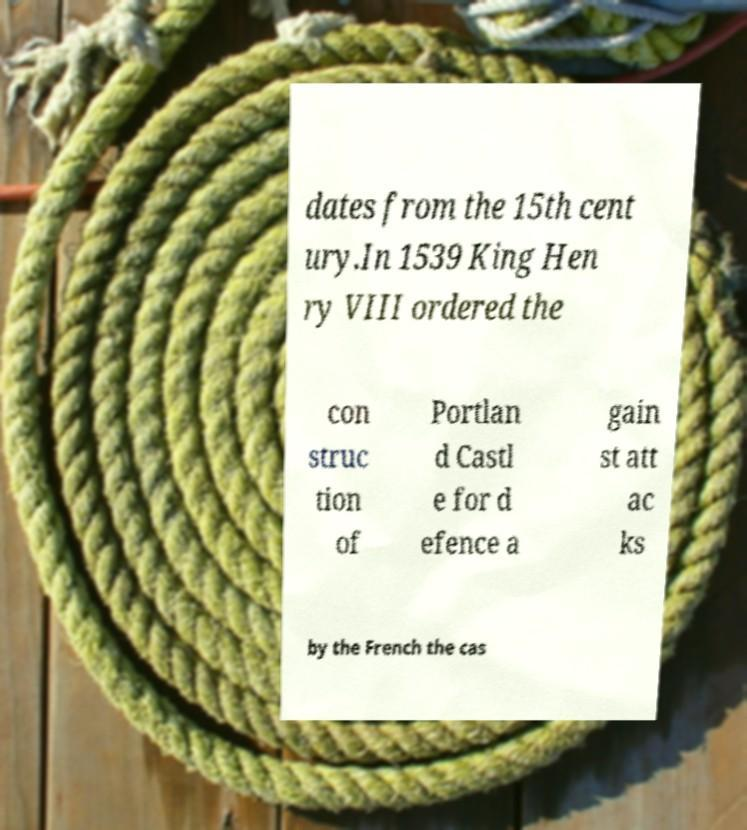I need the written content from this picture converted into text. Can you do that? dates from the 15th cent ury.In 1539 King Hen ry VIII ordered the con struc tion of Portlan d Castl e for d efence a gain st att ac ks by the French the cas 